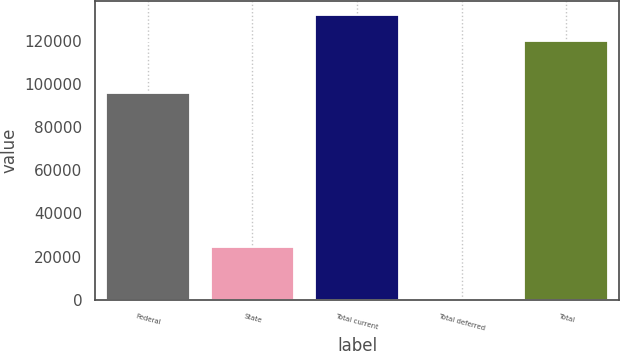Convert chart. <chart><loc_0><loc_0><loc_500><loc_500><bar_chart><fcel>Federal<fcel>State<fcel>Total current<fcel>Total deferred<fcel>Total<nl><fcel>95946<fcel>24327<fcel>131981<fcel>290<fcel>119983<nl></chart> 